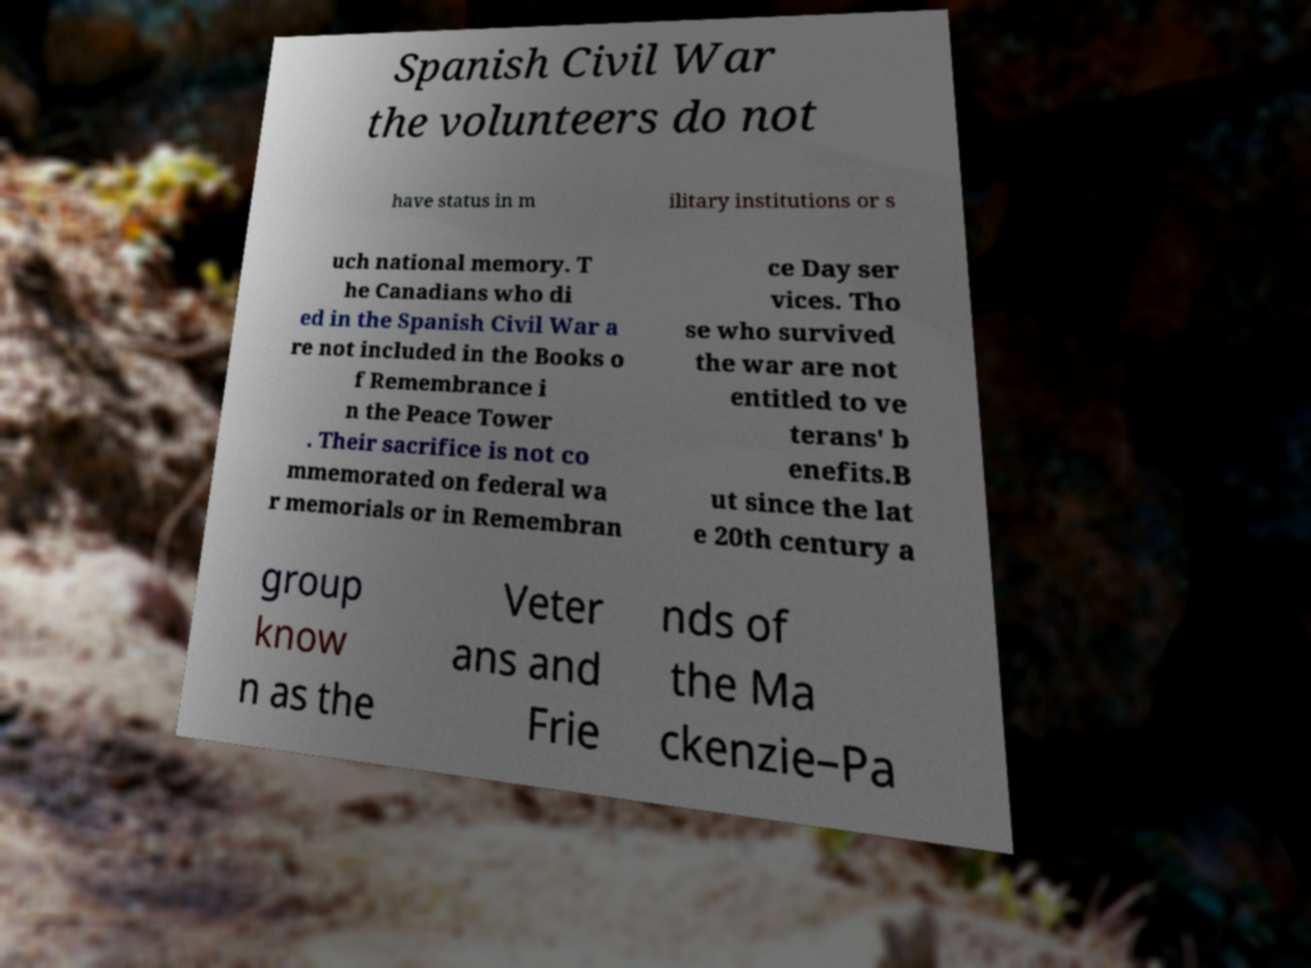Please read and relay the text visible in this image. What does it say? Spanish Civil War the volunteers do not have status in m ilitary institutions or s uch national memory. T he Canadians who di ed in the Spanish Civil War a re not included in the Books o f Remembrance i n the Peace Tower . Their sacrifice is not co mmemorated on federal wa r memorials or in Remembran ce Day ser vices. Tho se who survived the war are not entitled to ve terans' b enefits.B ut since the lat e 20th century a group know n as the Veter ans and Frie nds of the Ma ckenzie–Pa 